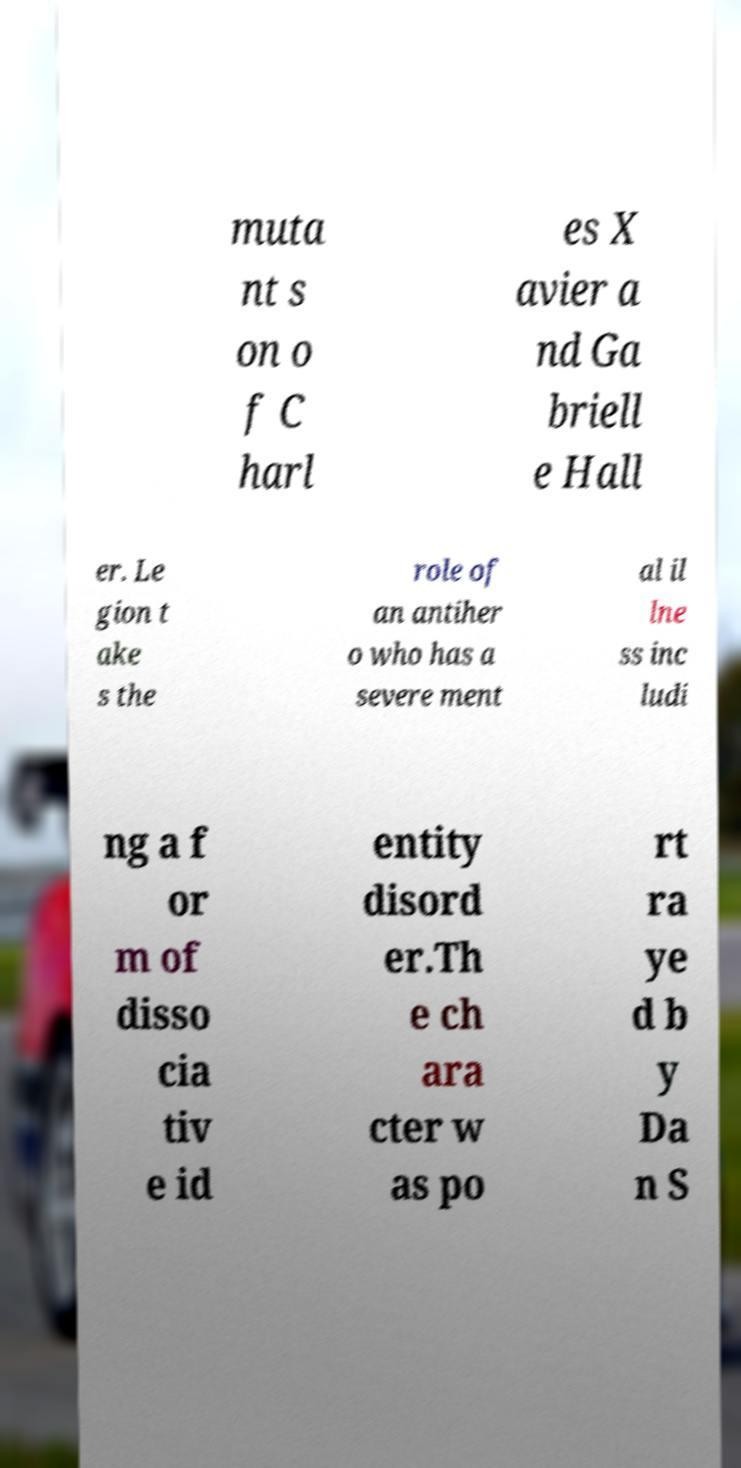I need the written content from this picture converted into text. Can you do that? muta nt s on o f C harl es X avier a nd Ga briell e Hall er. Le gion t ake s the role of an antiher o who has a severe ment al il lne ss inc ludi ng a f or m of disso cia tiv e id entity disord er.Th e ch ara cter w as po rt ra ye d b y Da n S 